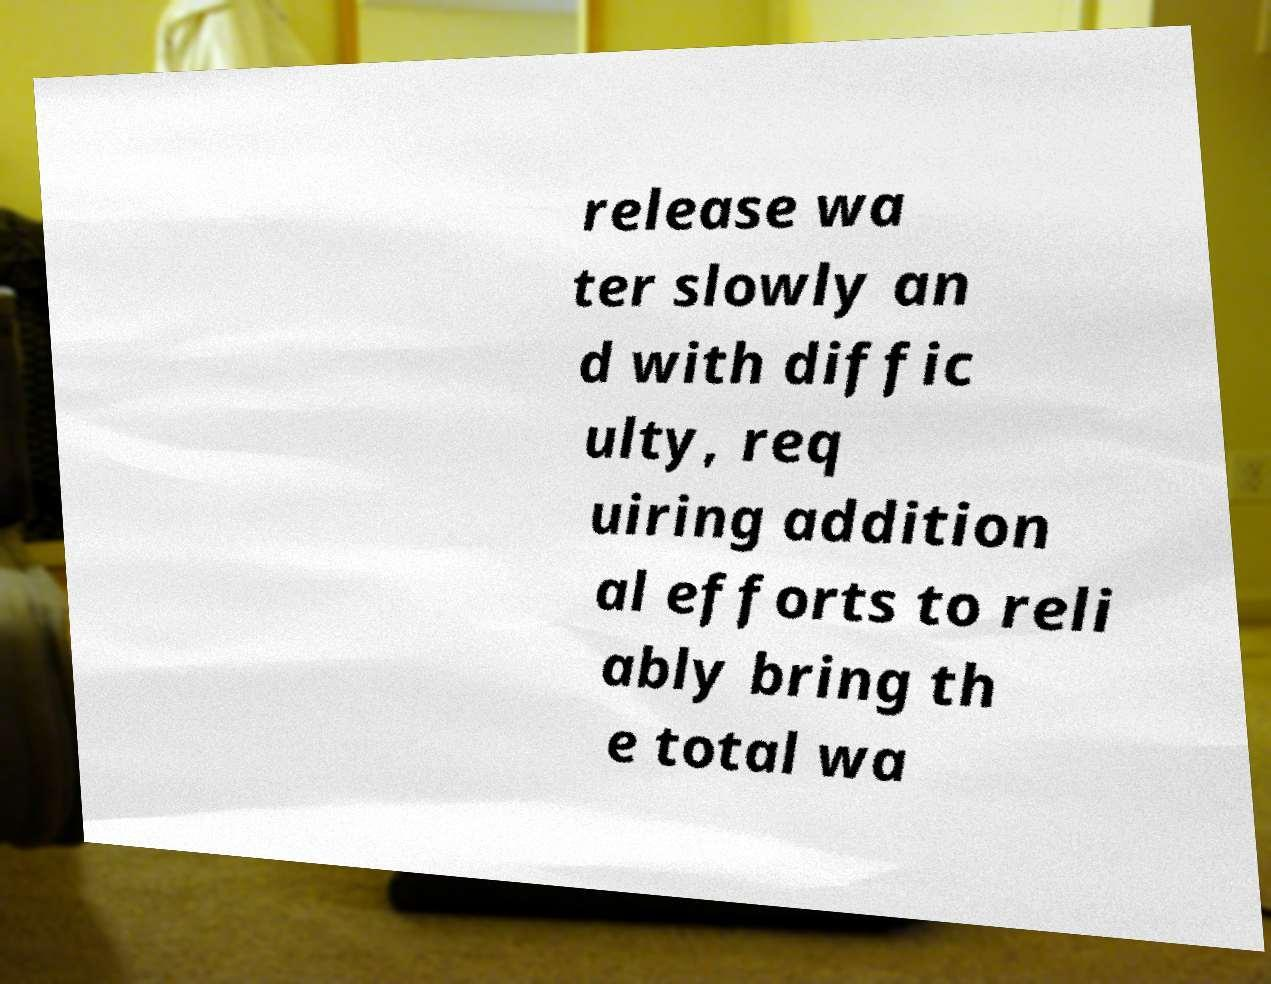Please read and relay the text visible in this image. What does it say? release wa ter slowly an d with diffic ulty, req uiring addition al efforts to reli ably bring th e total wa 